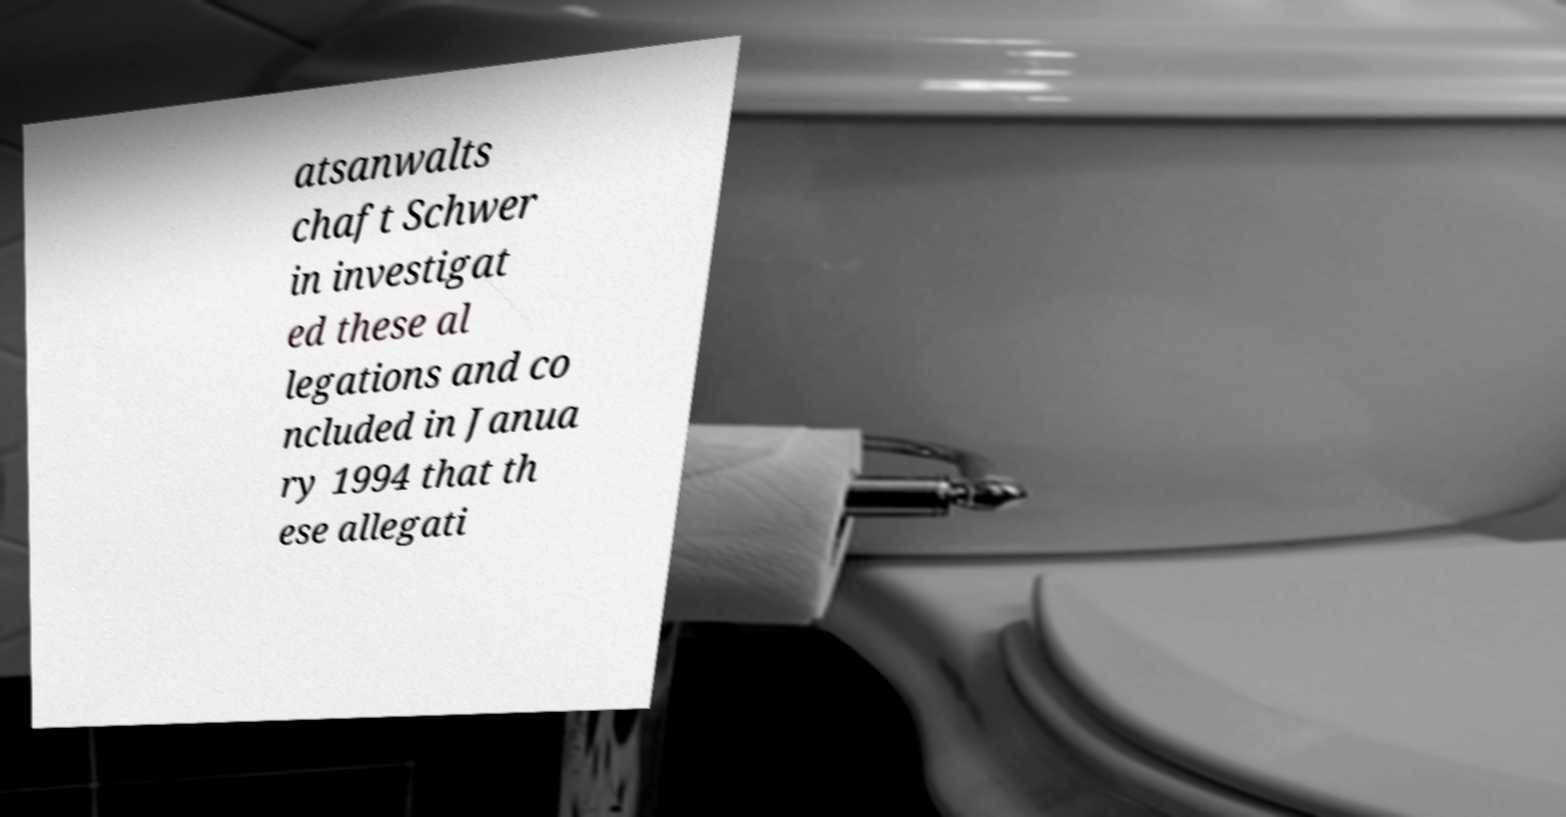Please identify and transcribe the text found in this image. atsanwalts chaft Schwer in investigat ed these al legations and co ncluded in Janua ry 1994 that th ese allegati 